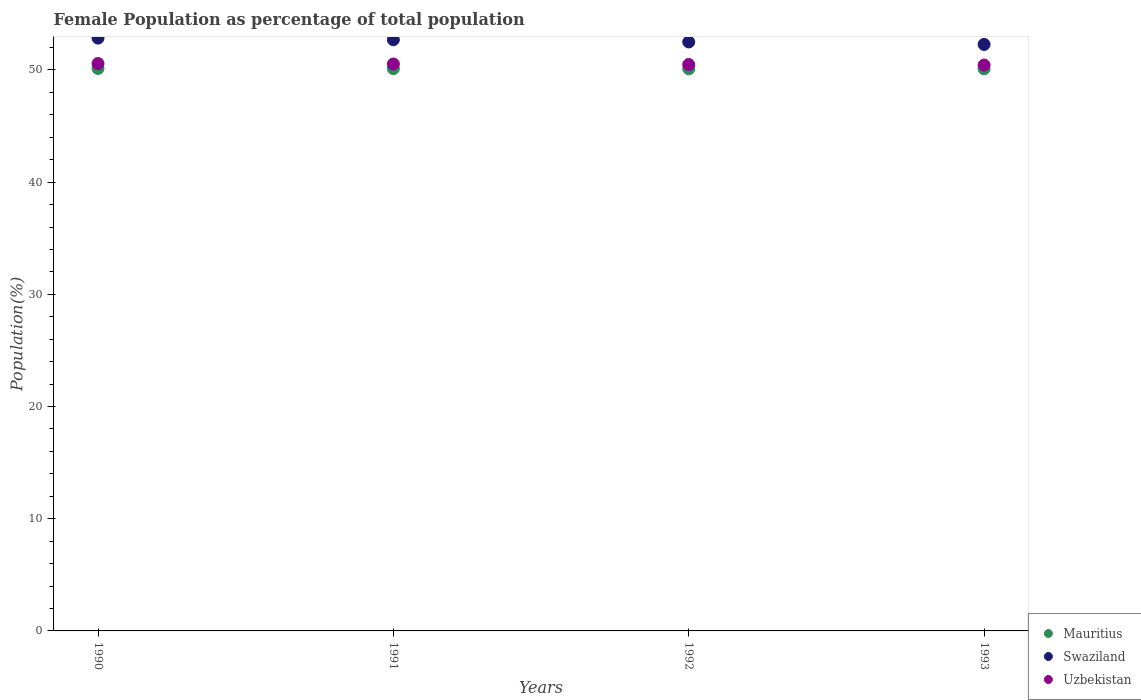Is the number of dotlines equal to the number of legend labels?
Offer a terse response. Yes. What is the female population in in Swaziland in 1991?
Offer a very short reply. 52.69. Across all years, what is the maximum female population in in Mauritius?
Your answer should be compact. 50.13. Across all years, what is the minimum female population in in Mauritius?
Make the answer very short. 50.1. In which year was the female population in in Swaziland minimum?
Offer a very short reply. 1993. What is the total female population in in Swaziland in the graph?
Your answer should be compact. 210.3. What is the difference between the female population in in Uzbekistan in 1992 and that in 1993?
Make the answer very short. 0.05. What is the difference between the female population in in Swaziland in 1991 and the female population in in Mauritius in 1990?
Your answer should be compact. 2.56. What is the average female population in in Swaziland per year?
Offer a terse response. 52.57. In the year 1992, what is the difference between the female population in in Mauritius and female population in in Uzbekistan?
Provide a short and direct response. -0.38. What is the ratio of the female population in in Mauritius in 1990 to that in 1993?
Provide a short and direct response. 1. Is the difference between the female population in in Mauritius in 1990 and 1991 greater than the difference between the female population in in Uzbekistan in 1990 and 1991?
Offer a terse response. No. What is the difference between the highest and the second highest female population in in Swaziland?
Offer a terse response. 0.14. What is the difference between the highest and the lowest female population in in Swaziland?
Offer a very short reply. 0.56. Is it the case that in every year, the sum of the female population in in Uzbekistan and female population in in Swaziland  is greater than the female population in in Mauritius?
Your answer should be very brief. Yes. Does the female population in in Swaziland monotonically increase over the years?
Offer a terse response. No. Is the female population in in Mauritius strictly greater than the female population in in Swaziland over the years?
Provide a succinct answer. No. Is the female population in in Uzbekistan strictly less than the female population in in Mauritius over the years?
Ensure brevity in your answer.  No. How many dotlines are there?
Your answer should be very brief. 3. Does the graph contain any zero values?
Make the answer very short. No. Where does the legend appear in the graph?
Provide a short and direct response. Bottom right. How many legend labels are there?
Keep it short and to the point. 3. What is the title of the graph?
Provide a short and direct response. Female Population as percentage of total population. Does "Guatemala" appear as one of the legend labels in the graph?
Offer a very short reply. No. What is the label or title of the X-axis?
Your response must be concise. Years. What is the label or title of the Y-axis?
Give a very brief answer. Population(%). What is the Population(%) in Mauritius in 1990?
Your answer should be compact. 50.13. What is the Population(%) in Swaziland in 1990?
Ensure brevity in your answer.  52.84. What is the Population(%) in Uzbekistan in 1990?
Offer a terse response. 50.57. What is the Population(%) in Mauritius in 1991?
Keep it short and to the point. 50.11. What is the Population(%) of Swaziland in 1991?
Provide a short and direct response. 52.69. What is the Population(%) in Uzbekistan in 1991?
Give a very brief answer. 50.53. What is the Population(%) in Mauritius in 1992?
Your answer should be very brief. 50.1. What is the Population(%) of Swaziland in 1992?
Offer a very short reply. 52.5. What is the Population(%) in Uzbekistan in 1992?
Your response must be concise. 50.48. What is the Population(%) in Mauritius in 1993?
Provide a short and direct response. 50.1. What is the Population(%) of Swaziland in 1993?
Offer a very short reply. 52.27. What is the Population(%) in Uzbekistan in 1993?
Ensure brevity in your answer.  50.44. Across all years, what is the maximum Population(%) in Mauritius?
Your response must be concise. 50.13. Across all years, what is the maximum Population(%) in Swaziland?
Provide a short and direct response. 52.84. Across all years, what is the maximum Population(%) of Uzbekistan?
Ensure brevity in your answer.  50.57. Across all years, what is the minimum Population(%) in Mauritius?
Your answer should be compact. 50.1. Across all years, what is the minimum Population(%) of Swaziland?
Ensure brevity in your answer.  52.27. Across all years, what is the minimum Population(%) in Uzbekistan?
Your answer should be very brief. 50.44. What is the total Population(%) of Mauritius in the graph?
Ensure brevity in your answer.  200.45. What is the total Population(%) of Swaziland in the graph?
Provide a short and direct response. 210.3. What is the total Population(%) of Uzbekistan in the graph?
Give a very brief answer. 202.02. What is the difference between the Population(%) of Mauritius in 1990 and that in 1991?
Offer a terse response. 0.02. What is the difference between the Population(%) in Swaziland in 1990 and that in 1991?
Give a very brief answer. 0.14. What is the difference between the Population(%) in Uzbekistan in 1990 and that in 1991?
Your answer should be very brief. 0.04. What is the difference between the Population(%) of Mauritius in 1990 and that in 1992?
Your response must be concise. 0.03. What is the difference between the Population(%) of Swaziland in 1990 and that in 1992?
Give a very brief answer. 0.34. What is the difference between the Population(%) of Uzbekistan in 1990 and that in 1992?
Keep it short and to the point. 0.08. What is the difference between the Population(%) of Mauritius in 1990 and that in 1993?
Keep it short and to the point. 0.03. What is the difference between the Population(%) in Swaziland in 1990 and that in 1993?
Ensure brevity in your answer.  0.56. What is the difference between the Population(%) in Uzbekistan in 1990 and that in 1993?
Make the answer very short. 0.13. What is the difference between the Population(%) in Mauritius in 1991 and that in 1992?
Give a very brief answer. 0.01. What is the difference between the Population(%) of Swaziland in 1991 and that in 1992?
Give a very brief answer. 0.2. What is the difference between the Population(%) in Uzbekistan in 1991 and that in 1992?
Your answer should be compact. 0.05. What is the difference between the Population(%) of Mauritius in 1991 and that in 1993?
Offer a very short reply. 0.01. What is the difference between the Population(%) of Swaziland in 1991 and that in 1993?
Your answer should be very brief. 0.42. What is the difference between the Population(%) of Uzbekistan in 1991 and that in 1993?
Make the answer very short. 0.09. What is the difference between the Population(%) in Mauritius in 1992 and that in 1993?
Offer a very short reply. -0. What is the difference between the Population(%) of Swaziland in 1992 and that in 1993?
Your answer should be compact. 0.22. What is the difference between the Population(%) of Uzbekistan in 1992 and that in 1993?
Your answer should be very brief. 0.05. What is the difference between the Population(%) of Mauritius in 1990 and the Population(%) of Swaziland in 1991?
Ensure brevity in your answer.  -2.56. What is the difference between the Population(%) in Mauritius in 1990 and the Population(%) in Uzbekistan in 1991?
Keep it short and to the point. -0.4. What is the difference between the Population(%) of Swaziland in 1990 and the Population(%) of Uzbekistan in 1991?
Your answer should be very brief. 2.31. What is the difference between the Population(%) in Mauritius in 1990 and the Population(%) in Swaziland in 1992?
Offer a terse response. -2.36. What is the difference between the Population(%) in Mauritius in 1990 and the Population(%) in Uzbekistan in 1992?
Your answer should be very brief. -0.35. What is the difference between the Population(%) of Swaziland in 1990 and the Population(%) of Uzbekistan in 1992?
Your response must be concise. 2.35. What is the difference between the Population(%) of Mauritius in 1990 and the Population(%) of Swaziland in 1993?
Ensure brevity in your answer.  -2.14. What is the difference between the Population(%) of Mauritius in 1990 and the Population(%) of Uzbekistan in 1993?
Offer a terse response. -0.31. What is the difference between the Population(%) of Swaziland in 1990 and the Population(%) of Uzbekistan in 1993?
Provide a short and direct response. 2.4. What is the difference between the Population(%) in Mauritius in 1991 and the Population(%) in Swaziland in 1992?
Provide a short and direct response. -2.38. What is the difference between the Population(%) in Mauritius in 1991 and the Population(%) in Uzbekistan in 1992?
Give a very brief answer. -0.37. What is the difference between the Population(%) of Swaziland in 1991 and the Population(%) of Uzbekistan in 1992?
Offer a very short reply. 2.21. What is the difference between the Population(%) of Mauritius in 1991 and the Population(%) of Swaziland in 1993?
Ensure brevity in your answer.  -2.16. What is the difference between the Population(%) in Mauritius in 1991 and the Population(%) in Uzbekistan in 1993?
Your response must be concise. -0.33. What is the difference between the Population(%) of Swaziland in 1991 and the Population(%) of Uzbekistan in 1993?
Give a very brief answer. 2.25. What is the difference between the Population(%) of Mauritius in 1992 and the Population(%) of Swaziland in 1993?
Provide a succinct answer. -2.17. What is the difference between the Population(%) of Mauritius in 1992 and the Population(%) of Uzbekistan in 1993?
Your response must be concise. -0.34. What is the difference between the Population(%) of Swaziland in 1992 and the Population(%) of Uzbekistan in 1993?
Your answer should be very brief. 2.06. What is the average Population(%) in Mauritius per year?
Offer a terse response. 50.11. What is the average Population(%) in Swaziland per year?
Provide a succinct answer. 52.58. What is the average Population(%) in Uzbekistan per year?
Your answer should be very brief. 50.51. In the year 1990, what is the difference between the Population(%) in Mauritius and Population(%) in Swaziland?
Provide a short and direct response. -2.71. In the year 1990, what is the difference between the Population(%) of Mauritius and Population(%) of Uzbekistan?
Your answer should be very brief. -0.44. In the year 1990, what is the difference between the Population(%) of Swaziland and Population(%) of Uzbekistan?
Make the answer very short. 2.27. In the year 1991, what is the difference between the Population(%) in Mauritius and Population(%) in Swaziland?
Your answer should be compact. -2.58. In the year 1991, what is the difference between the Population(%) in Mauritius and Population(%) in Uzbekistan?
Your answer should be very brief. -0.42. In the year 1991, what is the difference between the Population(%) of Swaziland and Population(%) of Uzbekistan?
Offer a terse response. 2.16. In the year 1992, what is the difference between the Population(%) of Mauritius and Population(%) of Swaziland?
Your answer should be compact. -2.39. In the year 1992, what is the difference between the Population(%) in Mauritius and Population(%) in Uzbekistan?
Your answer should be very brief. -0.38. In the year 1992, what is the difference between the Population(%) of Swaziland and Population(%) of Uzbekistan?
Your response must be concise. 2.01. In the year 1993, what is the difference between the Population(%) in Mauritius and Population(%) in Swaziland?
Your response must be concise. -2.17. In the year 1993, what is the difference between the Population(%) in Mauritius and Population(%) in Uzbekistan?
Keep it short and to the point. -0.33. In the year 1993, what is the difference between the Population(%) of Swaziland and Population(%) of Uzbekistan?
Your answer should be compact. 1.84. What is the ratio of the Population(%) of Mauritius in 1990 to that in 1991?
Offer a very short reply. 1. What is the ratio of the Population(%) in Swaziland in 1990 to that in 1992?
Give a very brief answer. 1.01. What is the ratio of the Population(%) in Swaziland in 1990 to that in 1993?
Make the answer very short. 1.01. What is the ratio of the Population(%) of Mauritius in 1991 to that in 1992?
Offer a very short reply. 1. What is the ratio of the Population(%) in Mauritius in 1991 to that in 1993?
Offer a terse response. 1. What is the ratio of the Population(%) of Swaziland in 1991 to that in 1993?
Ensure brevity in your answer.  1.01. What is the ratio of the Population(%) in Swaziland in 1992 to that in 1993?
Provide a succinct answer. 1. What is the ratio of the Population(%) of Uzbekistan in 1992 to that in 1993?
Give a very brief answer. 1. What is the difference between the highest and the second highest Population(%) in Mauritius?
Give a very brief answer. 0.02. What is the difference between the highest and the second highest Population(%) in Swaziland?
Provide a short and direct response. 0.14. What is the difference between the highest and the second highest Population(%) of Uzbekistan?
Your answer should be very brief. 0.04. What is the difference between the highest and the lowest Population(%) in Mauritius?
Provide a short and direct response. 0.03. What is the difference between the highest and the lowest Population(%) of Swaziland?
Ensure brevity in your answer.  0.56. What is the difference between the highest and the lowest Population(%) in Uzbekistan?
Provide a short and direct response. 0.13. 